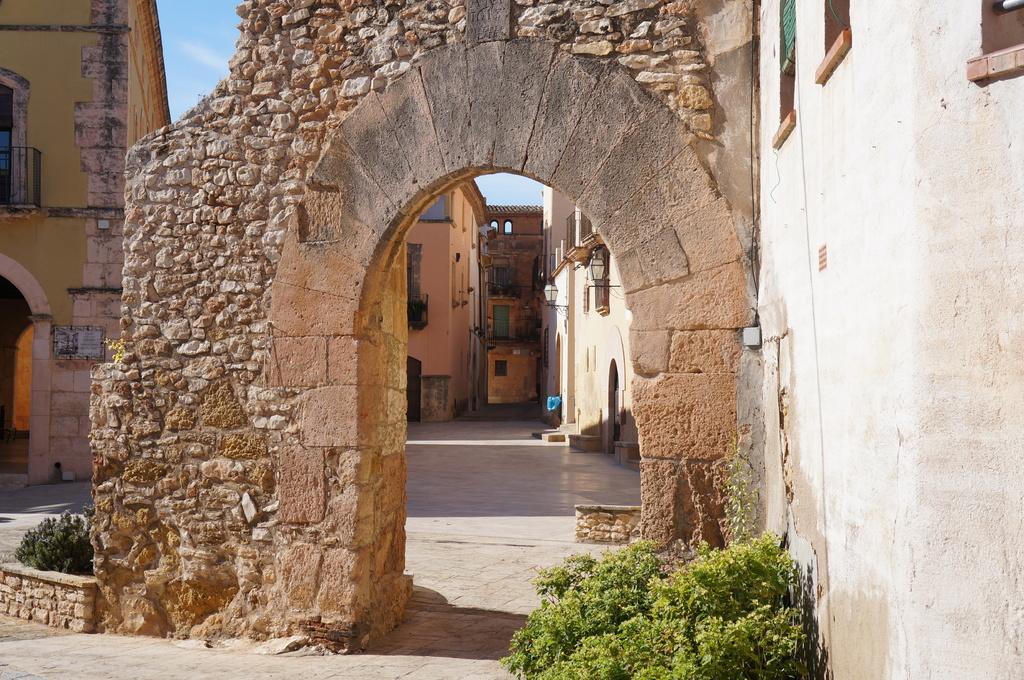Could you give a brief overview of what you see in this image? In this image there is a stone wall with the entrance in the middle. In the background there are buildings. At the bottom on the right side there are small plants. At the top there is sky. 